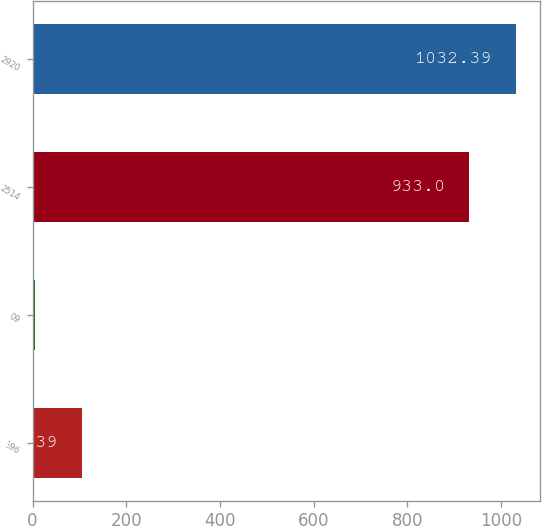Convert chart. <chart><loc_0><loc_0><loc_500><loc_500><bar_chart><fcel>396<fcel>09<fcel>2514<fcel>2920<nl><fcel>105.39<fcel>6<fcel>933<fcel>1032.39<nl></chart> 